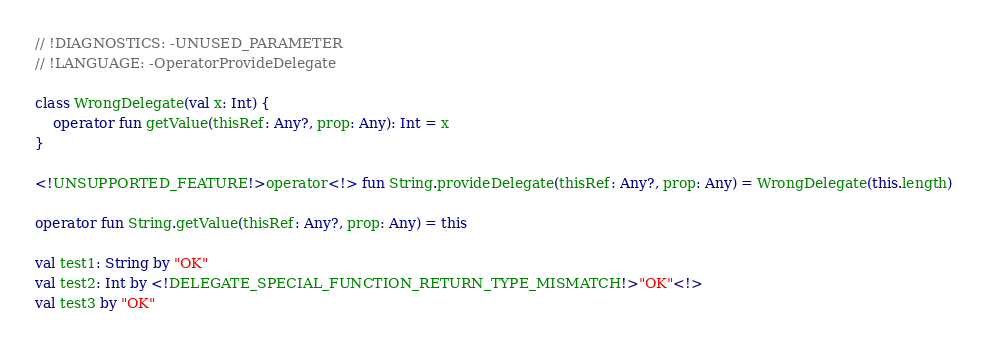<code> <loc_0><loc_0><loc_500><loc_500><_Kotlin_>// !DIAGNOSTICS: -UNUSED_PARAMETER
// !LANGUAGE: -OperatorProvideDelegate

class WrongDelegate(val x: Int) {
    operator fun getValue(thisRef: Any?, prop: Any): Int = x
}

<!UNSUPPORTED_FEATURE!>operator<!> fun String.provideDelegate(thisRef: Any?, prop: Any) = WrongDelegate(this.length)

operator fun String.getValue(thisRef: Any?, prop: Any) = this

val test1: String by "OK"
val test2: Int by <!DELEGATE_SPECIAL_FUNCTION_RETURN_TYPE_MISMATCH!>"OK"<!>
val test3 by "OK"</code> 